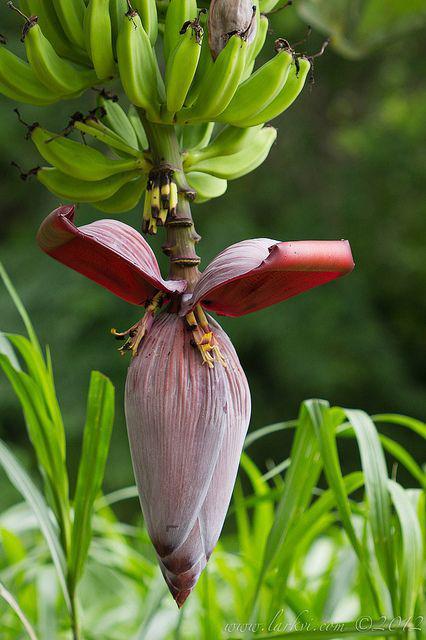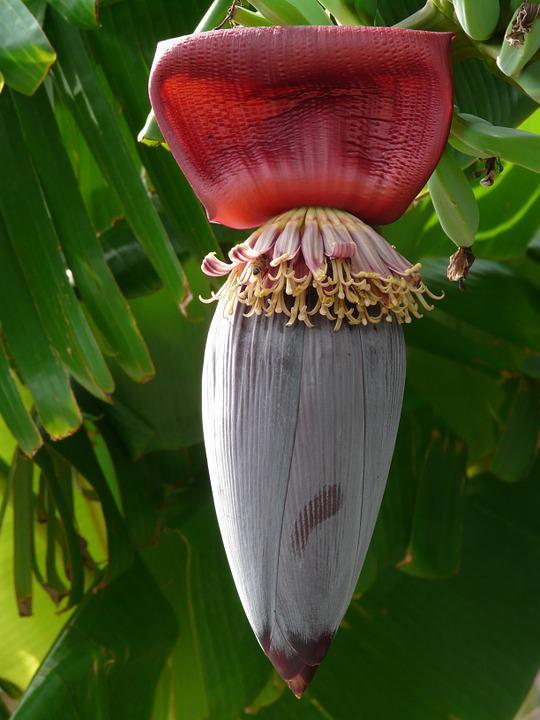The first image is the image on the left, the second image is the image on the right. For the images shown, is this caption "At the bottom of the bananas the flower has at least four petals open." true? Answer yes or no. No. The first image is the image on the left, the second image is the image on the right. Examine the images to the left and right. Is the description "There is exactly one flower petal in the left image." accurate? Answer yes or no. No. 